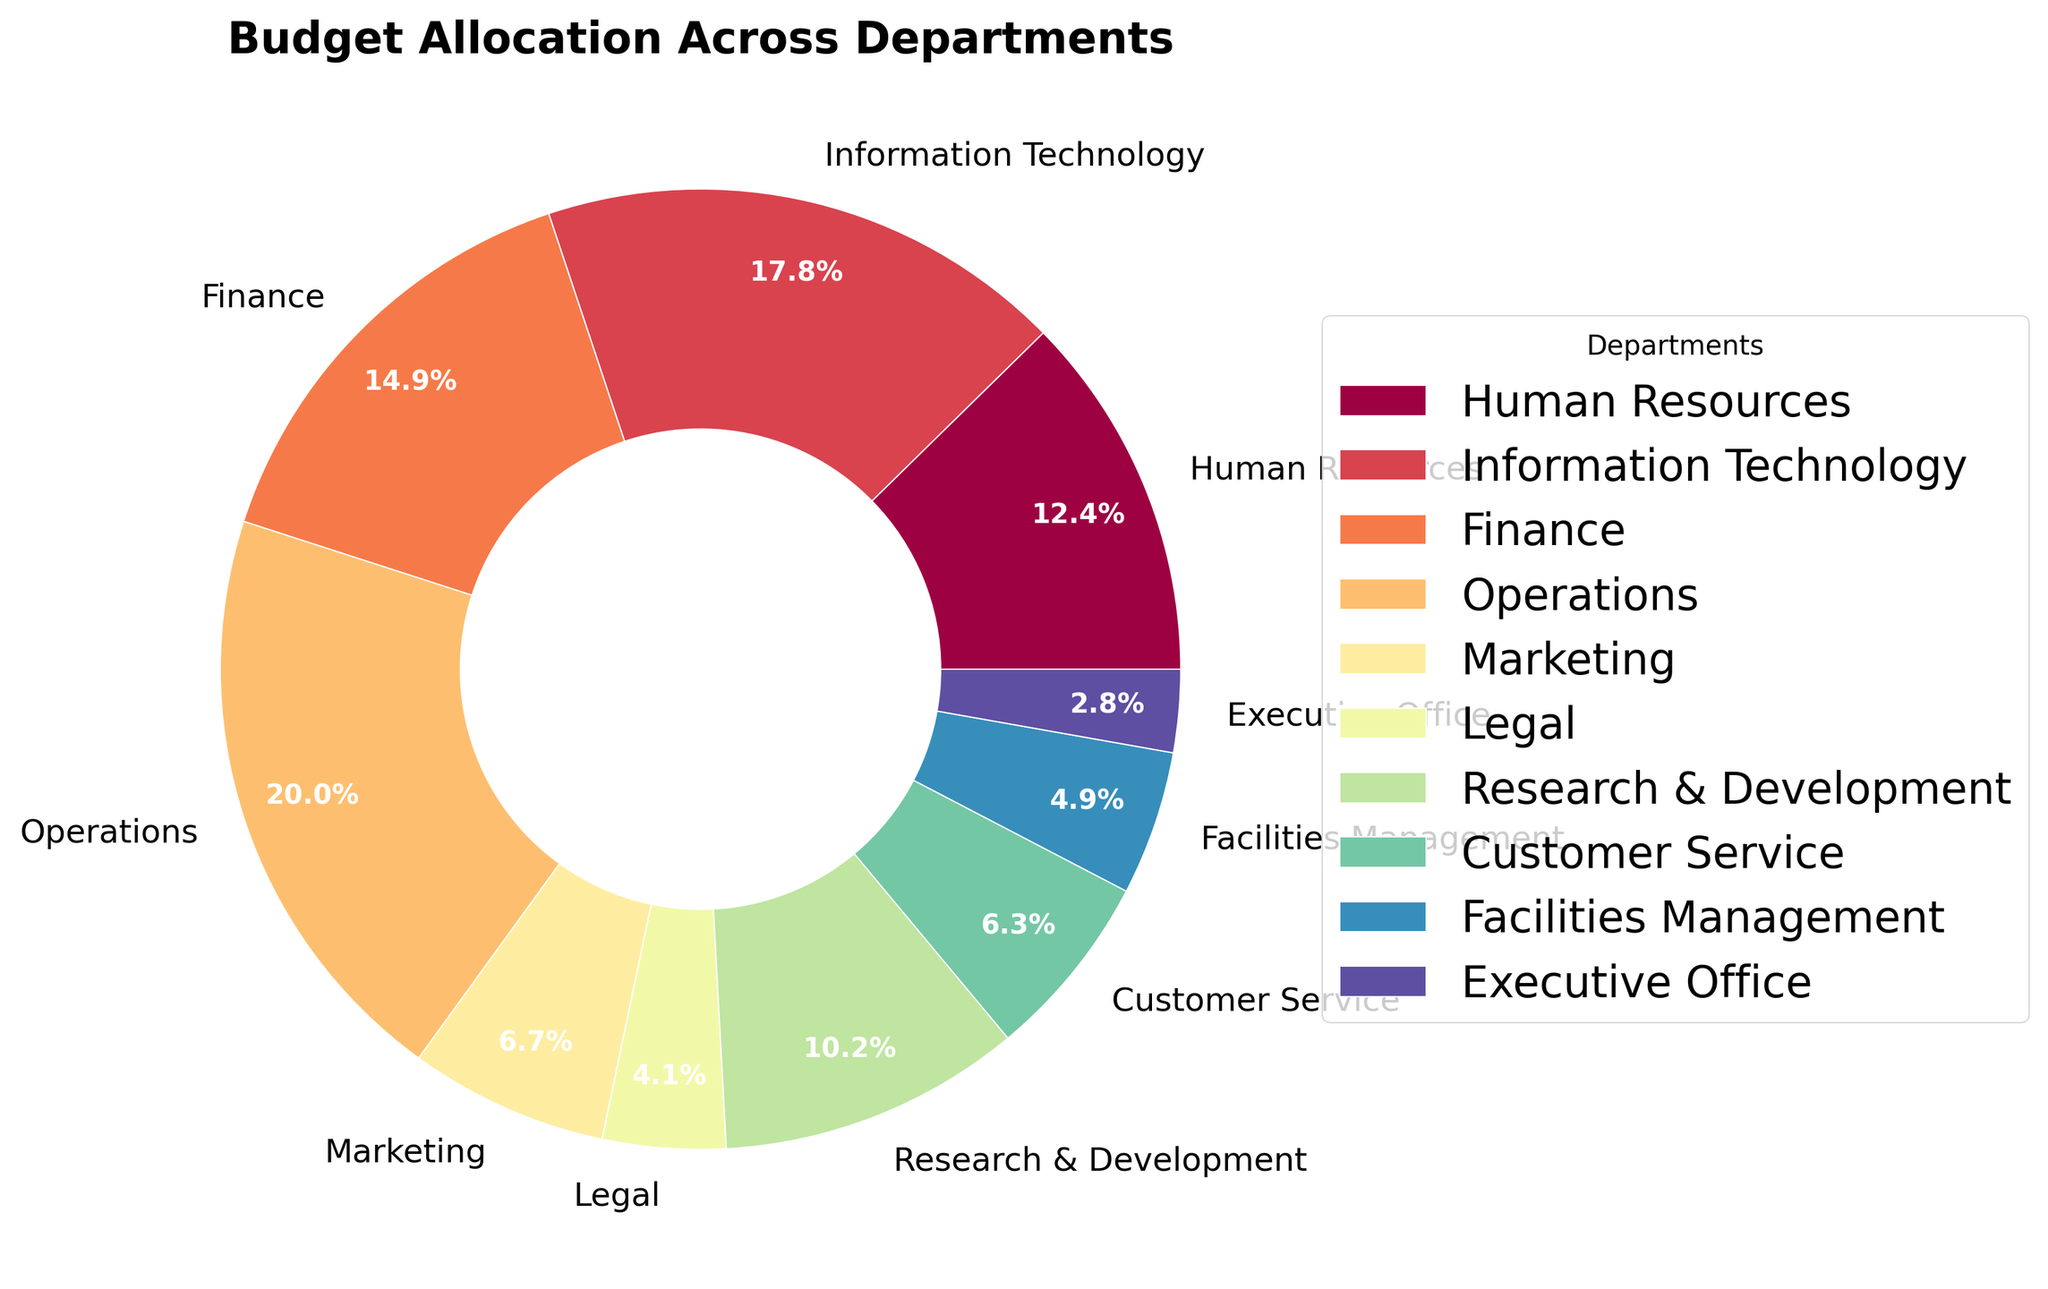Which department has the highest budget allocation? The Operations department has the highest budget allocation at 25.1% as observed from the pie chart.
Answer: Operations What is the combined budget allocation of the departments with the lowest and highest allocations? The departments with the lowest and highest allocations are the Executive Office (3.5%) and Operations (25.1%). Summing these, 3.5% + 25.1% = 28.6%.
Answer: 28.6% How does the budget allocation for Information Technology compare to Marketing? Information Technology has a higher budget allocation (22.3%) compared to Marketing (8.4%) as seen from their respective slices in the pie chart.
Answer: Information Technology Which three departments have the smallest budget allocations? The smallest budget allocations are to the Executive Office (3.5%), Legal (5.2%), and Facilities Management (6.1%) as they have the smallest slices in the pie chart.
Answer: Executive Office, Legal, Facilities Management What is the total budget allocation for Human Resources, Finance, and Customer Service? Adding the budget allocations for Human Resources (15.5%), Finance (18.7%), and Customer Service (7.9%), we get 15.5% + 18.7% + 7.9% = 42.1%.
Answer: 42.1% What percentage of the total budget is allocated to departments other than Operations? The allocation for Operations is 25.1%, so the remaining budget allocation is 100% - 25.1% = 74.9%.
Answer: 74.9% If the allocation to Research & Development increases by 2%, what will be its new percentage of the total budget? The current allocation for Research & Development is 12.8%. Increasing this by 2% gives a new allocation of 12.8% + 2% = 14.8%.
Answer: 14.8% By what percentage is the budget for Finance greater than that for the Executive Office? The budget allocations are 18.7% for Finance and 3.5% for the Executive Office. The difference is 18.7% - 3.5% = 15.2%. To find the percentage increase: (15.2% / 3.5%) * 100 ≈ 434.3%.
Answer: 434.3% What is the average budget allocation across all departments? Summing all budget allocations (15.5% + 22.3% + 18.7% + 25.1% + 8.4% + 5.2% + 12.8% + 7.9% + 6.1% + 3.5% = 125.5%) and dividing by the number of departments (10), the average allocation is 125.5% / 10 = 12.55%.
Answer: 12.55% How does the width of the slice for Finance compare to that for Legal as observed visually? The slice for Finance is significantly wider than that for Legal, indicating a higher budget allocation (18.7% vs. 5.2%).
Answer: Finance 